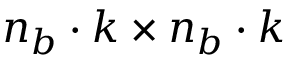<formula> <loc_0><loc_0><loc_500><loc_500>n _ { b } \cdot k \times n _ { b } \cdot k</formula> 